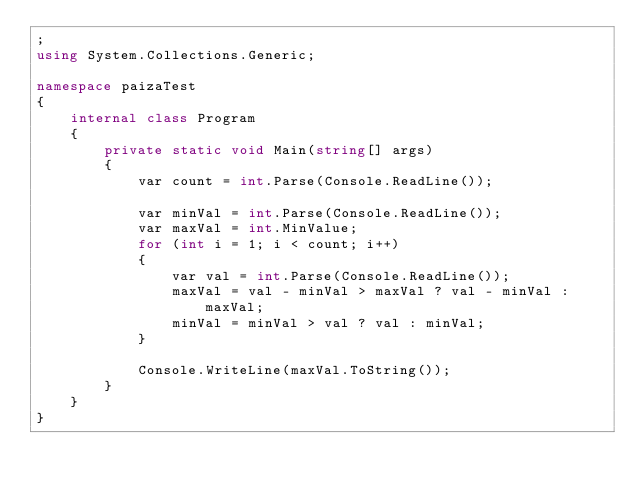Convert code to text. <code><loc_0><loc_0><loc_500><loc_500><_C#_>;
using System.Collections.Generic;

namespace paizaTest
{
    internal class Program
    {
        private static void Main(string[] args)
        {
            var count = int.Parse(Console.ReadLine());

            var minVal = int.Parse(Console.ReadLine());
            var maxVal = int.MinValue;
            for (int i = 1; i < count; i++)
            {
                var val = int.Parse(Console.ReadLine());
                maxVal = val - minVal > maxVal ? val - minVal : maxVal;
                minVal = minVal > val ? val : minVal;
            }

            Console.WriteLine(maxVal.ToString());
        }
    }
}</code> 